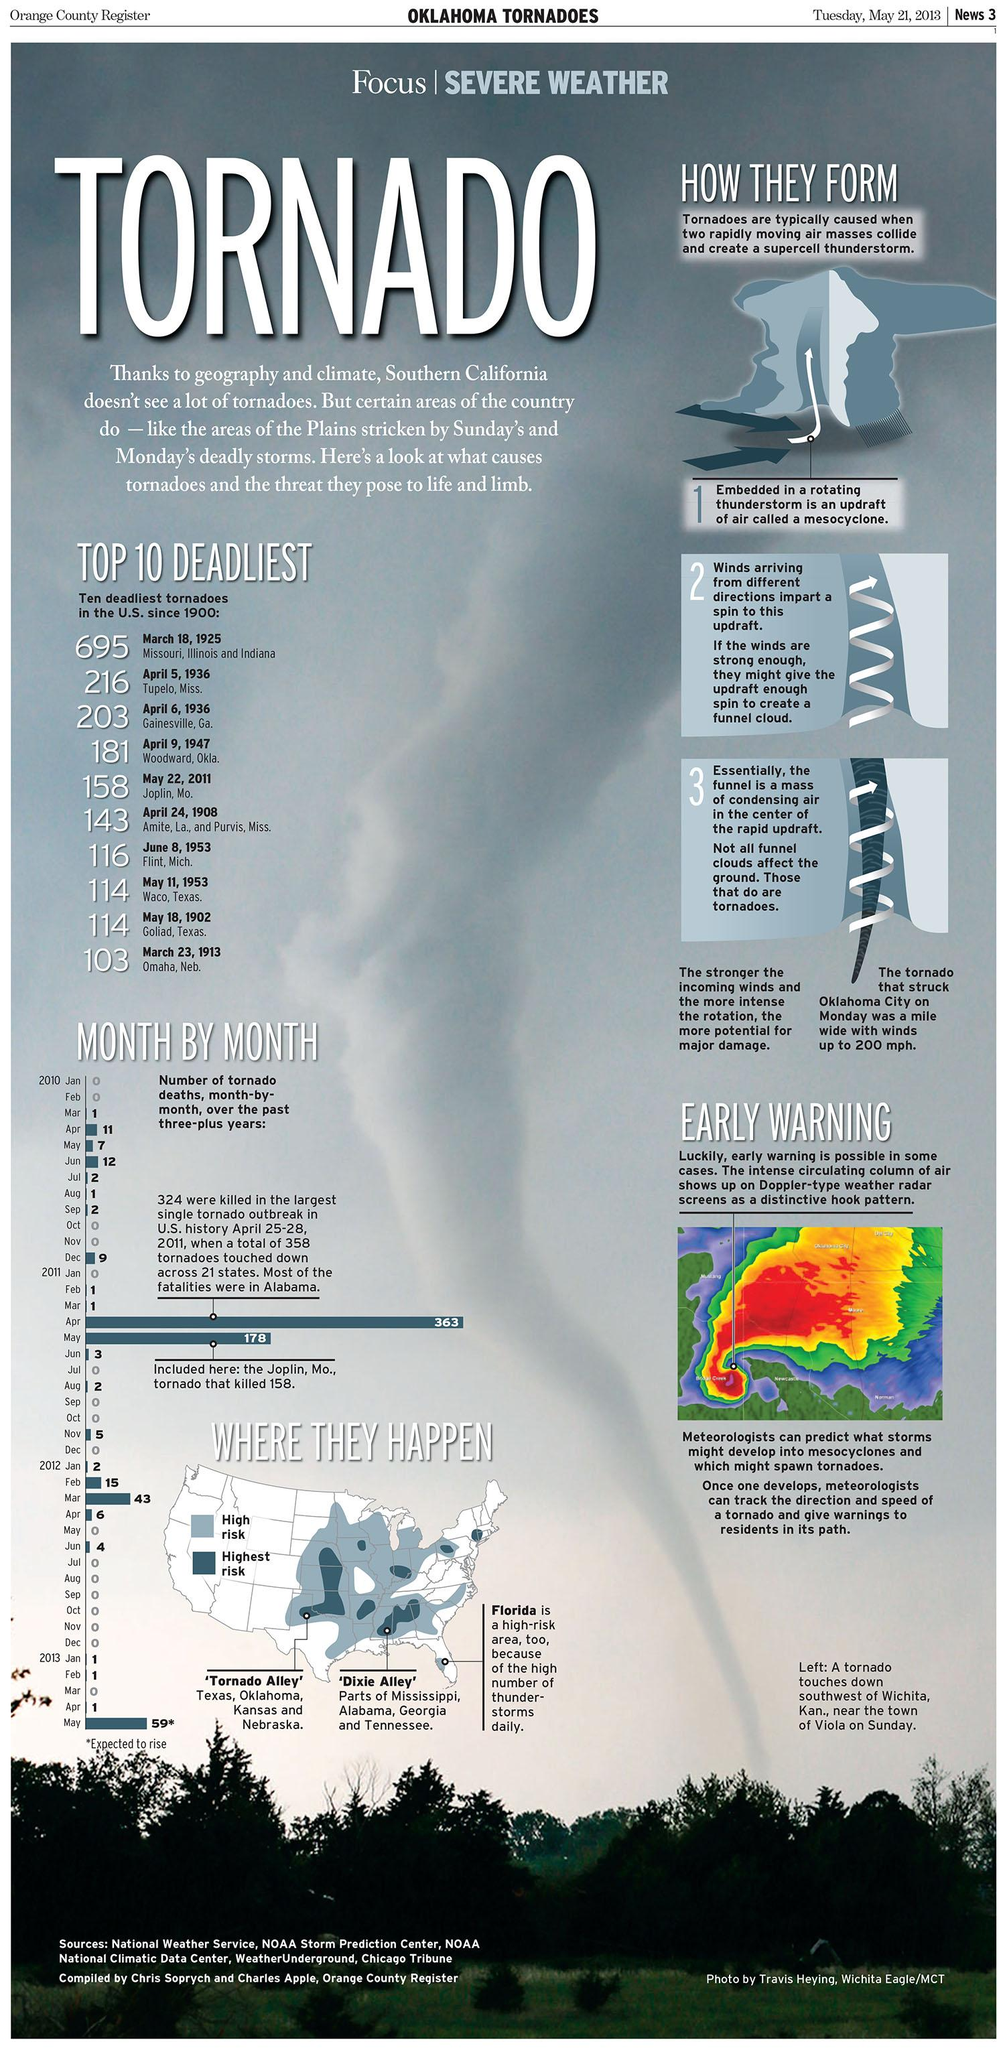Indicate a few pertinent items in this graphic. In 2012, the month with the highest number of tornado deaths in the United States was March. On March 18, 1925, the deadliest tornadoes struck several states in the United States, causing significant damage and loss of life in Missouri, Illinois, and Indiana. There were 12 tornado-related fatalities in the United States in June, 2010. On April 5, 1936, a tornado struck Tupelo, resulting in 216 deaths. There were no fatalities due to tornadoes in the United States in July, 2011. 